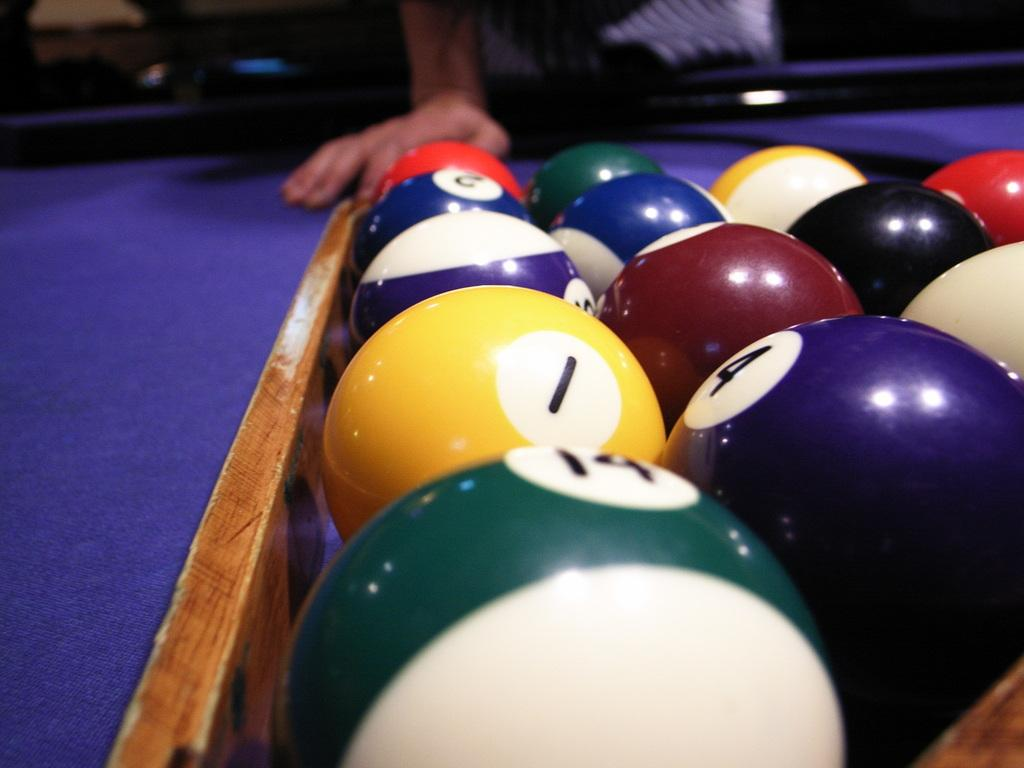What type of table is in the image? There is a billiards table in the image. What is on top of the billiards table? There are balls on the billiards table. Can you describe the person in the image? There is a person standing in the image. What type of shade is being used to protect the billiards table from the sun in the image? There is no shade present in the image; the billiards table and balls are indoors. How does the person in the image maintain their balance while playing billiards? The image does not show the person playing billiards, so it is not possible to determine how they maintain their balance. 